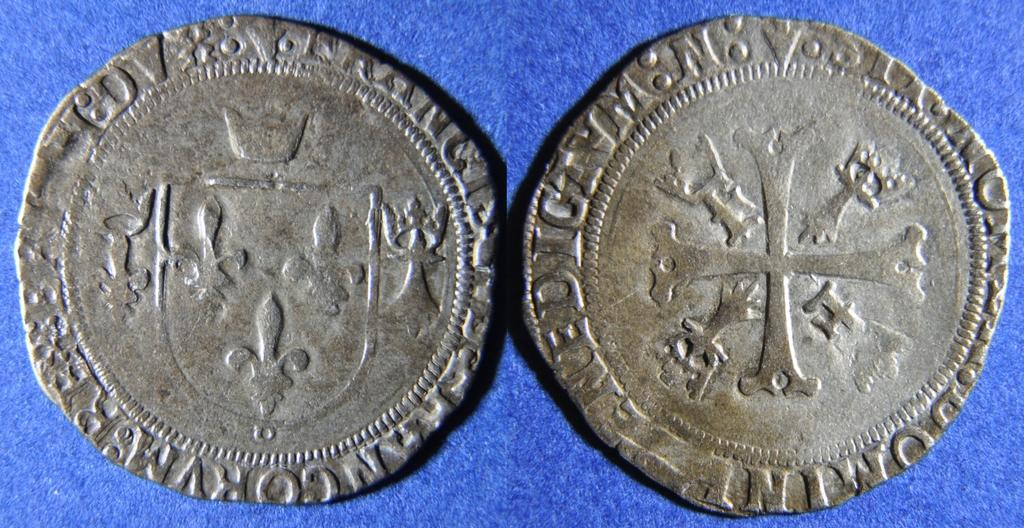What objects are present in the image? There are coins in the image. What is written on the coins? The coins have text written on them. What type of guide is present in the image? There is no guide present in the image; it only features coins with text written on them. 